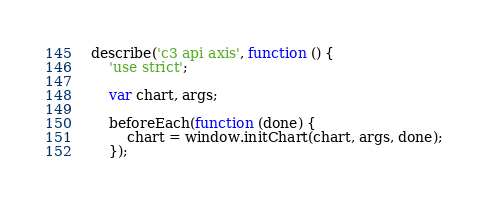Convert code to text. <code><loc_0><loc_0><loc_500><loc_500><_JavaScript_>describe('c3 api axis', function () {
    'use strict';

    var chart, args;

    beforeEach(function (done) {
        chart = window.initChart(chart, args, done);
    });
</code> 